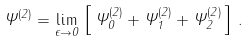<formula> <loc_0><loc_0><loc_500><loc_500>\Psi ^ { ( 2 ) } = \lim _ { \epsilon \to 0 } \, \left [ \, \Psi ^ { ( 2 ) } _ { 0 } + \Psi ^ { ( 2 ) } _ { 1 } + \Psi ^ { ( 2 ) } _ { 2 } \, \right ] \, .</formula> 